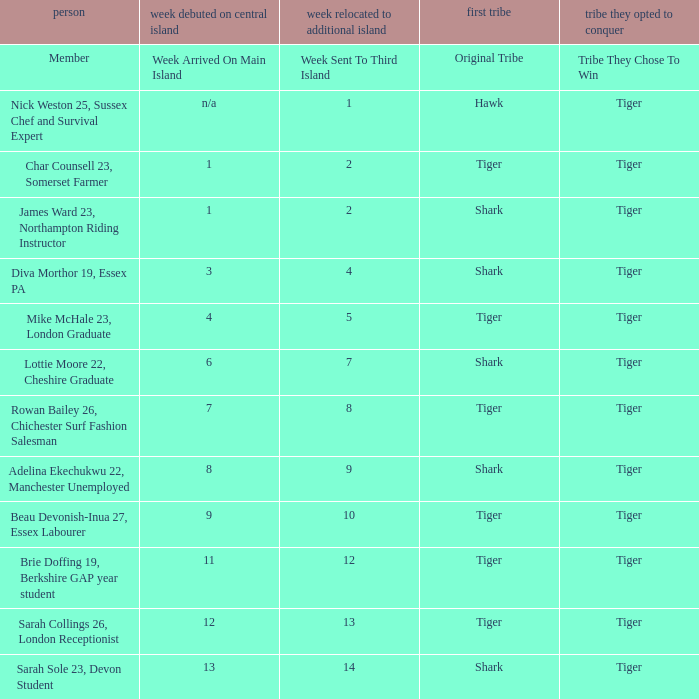What week was the member who arrived on the main island in week 6 sent to the third island? 7.0. 